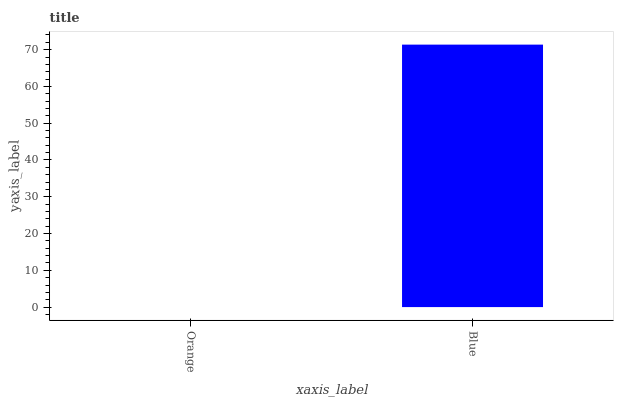Is Orange the minimum?
Answer yes or no. Yes. Is Blue the maximum?
Answer yes or no. Yes. Is Blue the minimum?
Answer yes or no. No. Is Blue greater than Orange?
Answer yes or no. Yes. Is Orange less than Blue?
Answer yes or no. Yes. Is Orange greater than Blue?
Answer yes or no. No. Is Blue less than Orange?
Answer yes or no. No. Is Blue the high median?
Answer yes or no. Yes. Is Orange the low median?
Answer yes or no. Yes. Is Orange the high median?
Answer yes or no. No. Is Blue the low median?
Answer yes or no. No. 